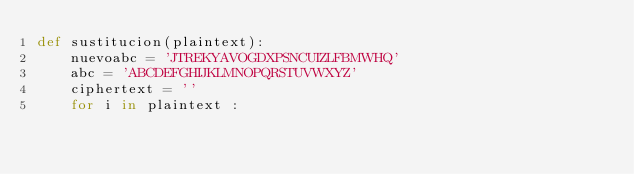Convert code to text. <code><loc_0><loc_0><loc_500><loc_500><_Python_>def sustitucion(plaintext):
    nuevoabc = 'JTREKYAVOGDXPSNCUIZLFBMWHQ'
    abc = 'ABCDEFGHIJKLMNOPQRSTUVWXYZ'
    ciphertext = ''
    for i in plaintext :</code> 